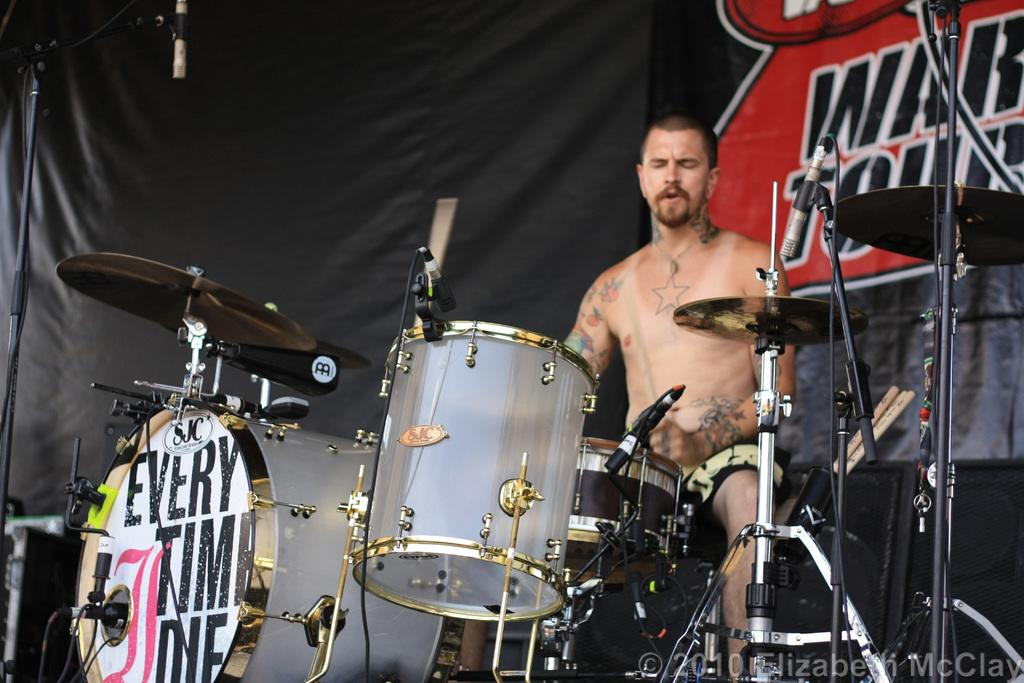What is the person in the image doing? There is a person sitting in the image. What else can be seen in the image besides the person? There are musical instruments, microphones, stands, and a black cloth in the image. What might the person be using the microphones for? The microphones in the image suggest that the person might be singing or speaking into them. What is written on the black cloth? Something is written on the black cloth, but the specific text is not mentioned in the facts. Can you tell me what hobbies the tiger in the image enjoys? There is no tiger present in the image; it features a person sitting with musical instruments, microphones, stands, and a black cloth. 